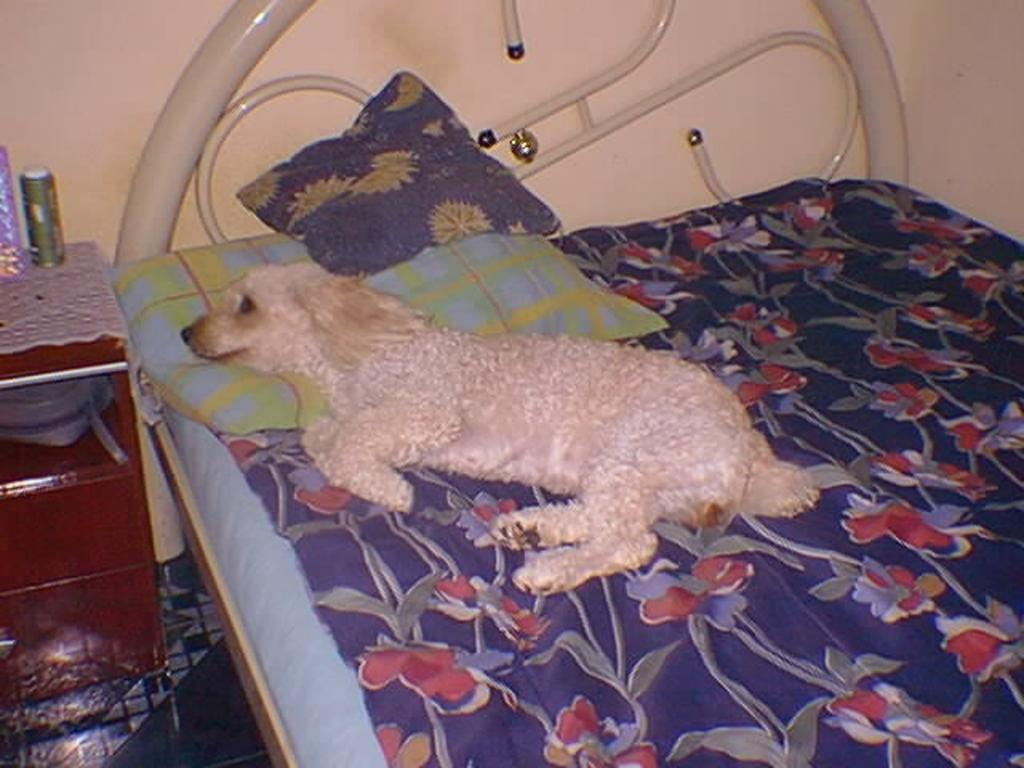What type of animal is in the image? There is a white dog in the image. What is the dog doing in the image? The dog is sleeping on the bed. What is covering part of the bed in the image? There is a colorful blanket in the image. What else can be seen on the bed? There are pillows in the image. What is visible on the cupboard in the image? There are objects on a cupboard in the image. What color is the wall in the image? The wall is in cream color. What is the dog's role in the ongoing war in the image? There is no war depicted in the image, and the dog is simply sleeping on the bed. How does the dog stretch on the bed in the image? The dog is sleeping, not stretching, in the image. 